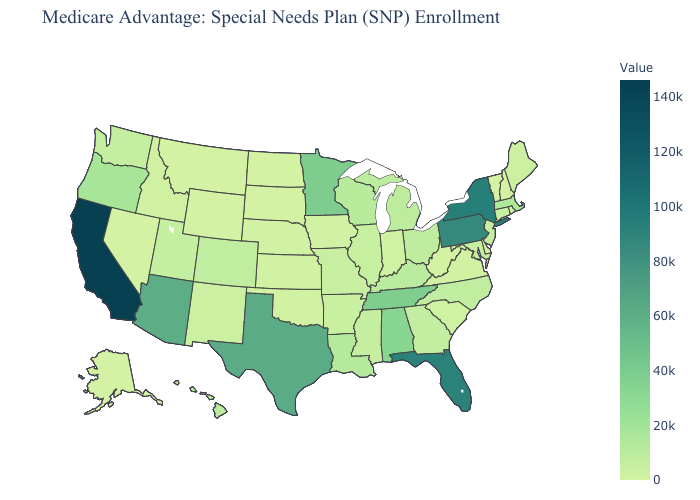Which states have the highest value in the USA?
Give a very brief answer. California. Which states have the highest value in the USA?
Keep it brief. California. Does New York have the highest value in the Northeast?
Give a very brief answer. Yes. Does North Carolina have a higher value than Tennessee?
Quick response, please. No. Does Illinois have the highest value in the MidWest?
Keep it brief. No. Among the states that border South Carolina , which have the lowest value?
Be succinct. Georgia. Among the states that border Tennessee , does Virginia have the lowest value?
Keep it brief. Yes. 